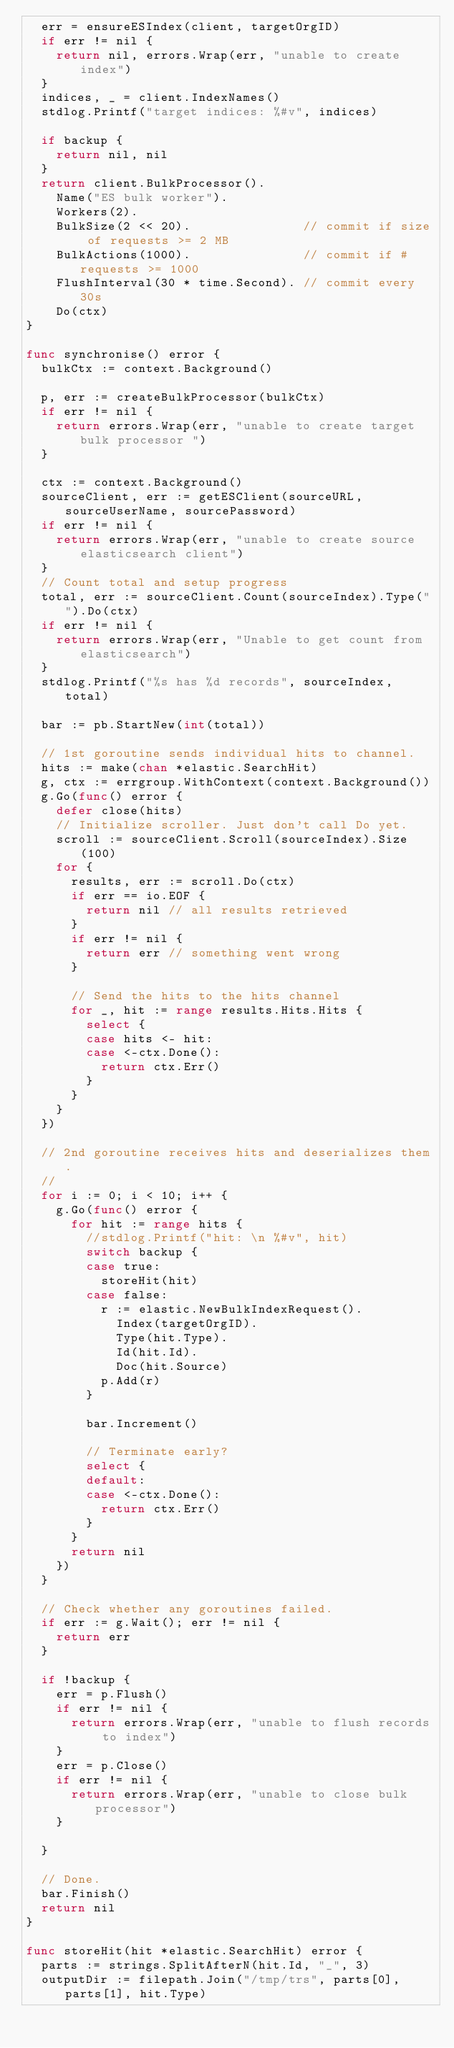<code> <loc_0><loc_0><loc_500><loc_500><_Go_>	err = ensureESIndex(client, targetOrgID)
	if err != nil {
		return nil, errors.Wrap(err, "unable to create index")
	}
	indices, _ = client.IndexNames()
	stdlog.Printf("target indices: %#v", indices)

	if backup {
		return nil, nil
	}
	return client.BulkProcessor().
		Name("ES bulk worker").
		Workers(2).
		BulkSize(2 << 20).               // commit if size of requests >= 2 MB
		BulkActions(1000).               // commit if # requests >= 1000
		FlushInterval(30 * time.Second). // commit every 30s
		Do(ctx)
}

func synchronise() error {
	bulkCtx := context.Background()

	p, err := createBulkProcessor(bulkCtx)
	if err != nil {
		return errors.Wrap(err, "unable to create target bulk processor ")
	}

	ctx := context.Background()
	sourceClient, err := getESClient(sourceURL, sourceUserName, sourcePassword)
	if err != nil {
		return errors.Wrap(err, "unable to create source elasticsearch client")
	}
	// Count total and setup progress
	total, err := sourceClient.Count(sourceIndex).Type("").Do(ctx)
	if err != nil {
		return errors.Wrap(err, "Unable to get count from elasticsearch")
	}
	stdlog.Printf("%s has %d records", sourceIndex, total)

	bar := pb.StartNew(int(total))

	// 1st goroutine sends individual hits to channel.
	hits := make(chan *elastic.SearchHit)
	g, ctx := errgroup.WithContext(context.Background())
	g.Go(func() error {
		defer close(hits)
		// Initialize scroller. Just don't call Do yet.
		scroll := sourceClient.Scroll(sourceIndex).Size(100)
		for {
			results, err := scroll.Do(ctx)
			if err == io.EOF {
				return nil // all results retrieved
			}
			if err != nil {
				return err // something went wrong
			}

			// Send the hits to the hits channel
			for _, hit := range results.Hits.Hits {
				select {
				case hits <- hit:
				case <-ctx.Done():
					return ctx.Err()
				}
			}
		}
	})

	// 2nd goroutine receives hits and deserializes them.
	//
	for i := 0; i < 10; i++ {
		g.Go(func() error {
			for hit := range hits {
				//stdlog.Printf("hit: \n %#v", hit)
				switch backup {
				case true:
					storeHit(hit)
				case false:
					r := elastic.NewBulkIndexRequest().
						Index(targetOrgID).
						Type(hit.Type).
						Id(hit.Id).
						Doc(hit.Source)
					p.Add(r)
				}

				bar.Increment()

				// Terminate early?
				select {
				default:
				case <-ctx.Done():
					return ctx.Err()
				}
			}
			return nil
		})
	}

	// Check whether any goroutines failed.
	if err := g.Wait(); err != nil {
		return err
	}

	if !backup {
		err = p.Flush()
		if err != nil {
			return errors.Wrap(err, "unable to flush records to index")
		}
		err = p.Close()
		if err != nil {
			return errors.Wrap(err, "unable to close bulk processor")
		}

	}

	// Done.
	bar.Finish()
	return nil
}

func storeHit(hit *elastic.SearchHit) error {
	parts := strings.SplitAfterN(hit.Id, "_", 3)
	outputDir := filepath.Join("/tmp/trs", parts[0], parts[1], hit.Type)</code> 